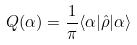Convert formula to latex. <formula><loc_0><loc_0><loc_500><loc_500>Q ( \alpha ) = \frac { 1 } { \pi } \langle \alpha | \hat { \rho } | \alpha \rangle</formula> 